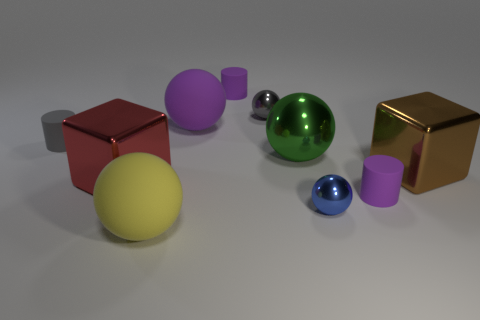How many other objects are there of the same size as the gray cylinder?
Your answer should be very brief. 4. What shape is the gray metal object that is the same size as the blue object?
Keep it short and to the point. Sphere. There is a big green thing; are there any tiny purple cylinders to the left of it?
Ensure brevity in your answer.  Yes. Is the size of the yellow object the same as the gray rubber cylinder?
Offer a terse response. No. There is a tiny gray object that is to the right of the tiny gray cylinder; what shape is it?
Your response must be concise. Sphere. Is there a gray metal object that has the same size as the yellow rubber object?
Keep it short and to the point. No. There is a blue sphere that is the same size as the gray ball; what material is it?
Offer a terse response. Metal. There is a shiny cube that is to the left of the big green shiny sphere; what size is it?
Provide a succinct answer. Large. What is the size of the yellow matte ball?
Give a very brief answer. Large. There is a blue thing; is its size the same as the rubber object that is in front of the tiny blue metallic object?
Offer a very short reply. No. 